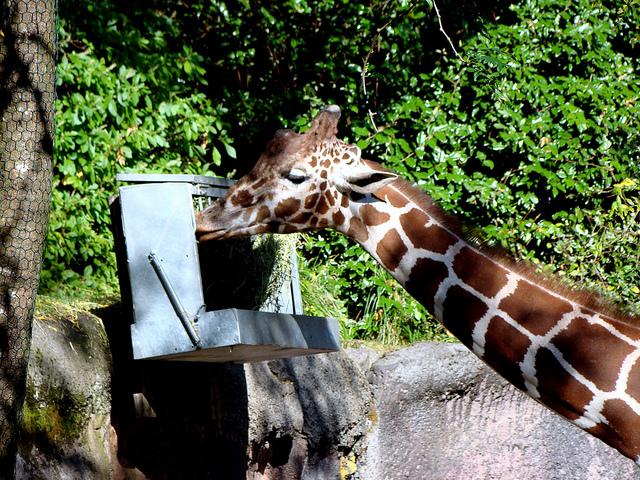Where is the animal?
Short answer required. Zoo. What is the giraffe eating?
Quick response, please. Hay. What animal is this?
Short answer required. Giraffe. What animal is eating?
Quick response, please. Giraffe. 